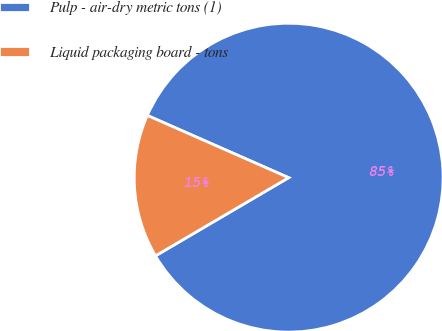Convert chart. <chart><loc_0><loc_0><loc_500><loc_500><pie_chart><fcel>Pulp - air-dry metric tons (1)<fcel>Liquid packaging board - tons<nl><fcel>84.95%<fcel>15.05%<nl></chart> 